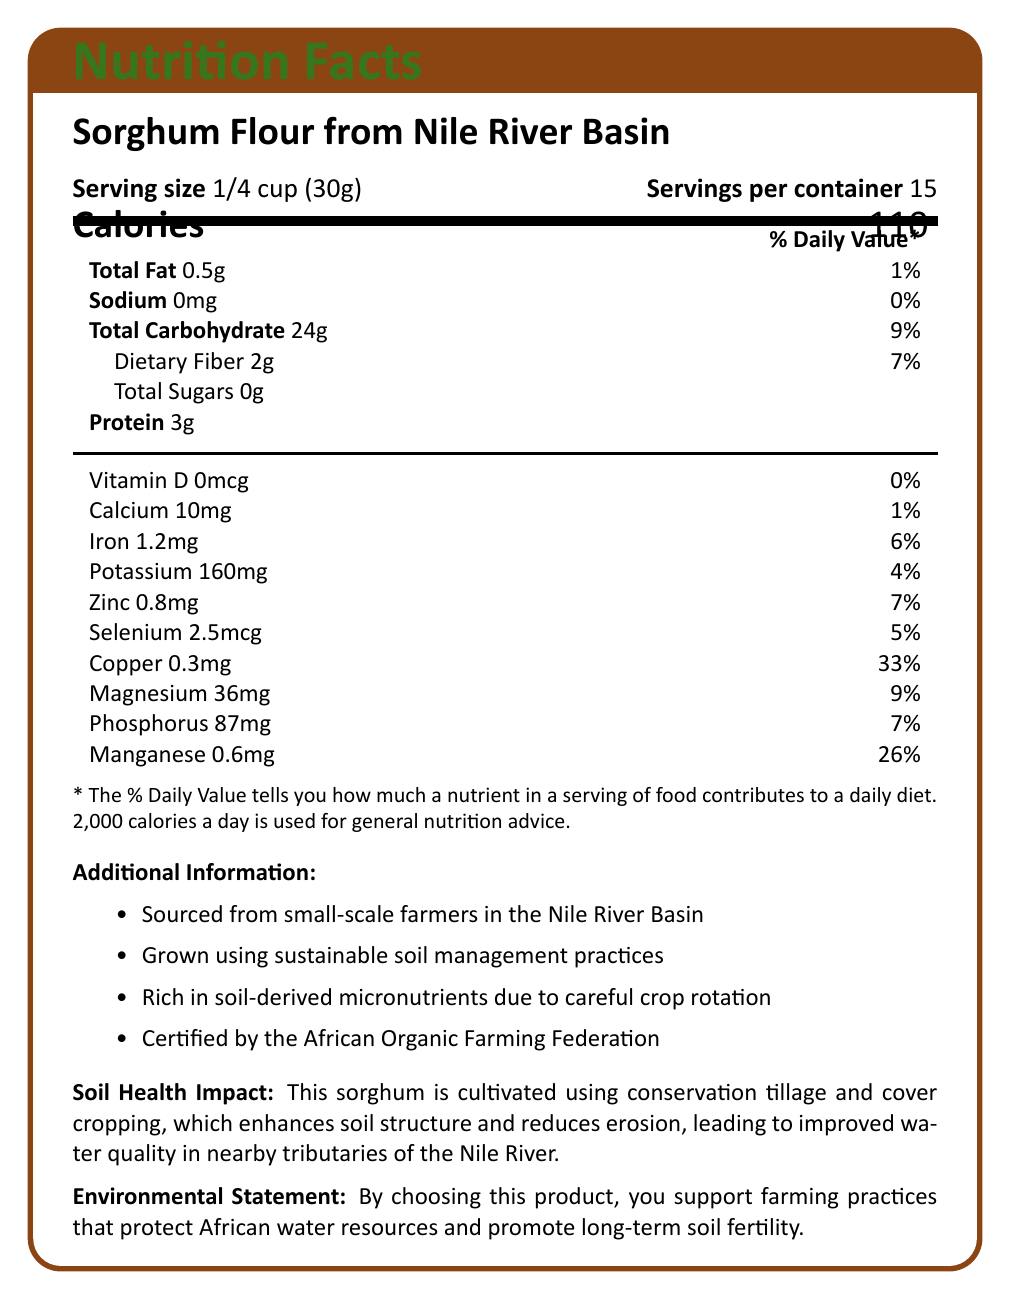what is the product name? The product name is displayed at the top of the document.
Answer: Sorghum Flour from Nile River Basin what is the serving size? The serving size is listed under the product name on the document.
Answer: 1/4 cup (30g) how many calories are in one serving? The caloric content per serving is listed in the section labeled "Calories."
Answer: 110 how much protein is in one serving? The amount of protein per serving is listed under the protein section.
Answer: 3g what percentage of the daily value for iron does one serving contain? The daily value percentage for iron is listed next to its amount.
Answer: 6% what is the total carbohydrate content per serving? A. 20g B. 24g C. 30g D. 36g The total carbohydrate content is listed under the "Total Carbohydrate" section.
Answer: B. 24g which nutrient has the highest daily value percentage? A. Sodium B. Calcium C. Copper D. Zinc Copper has a daily value percentage of 33%, which is the highest listed.
Answer: C. Copper is there any sodium in the product? The sodium content per serving is 0mg, as listed in the document.
Answer: No does this product support sustainable farming practices? The components under "Additional Information" and the "Environmental Statement" mention sustainable soil management practices and the protection of African water resources.
Answer: Yes what is the main idea of the document? The document includes detailed nutritional data, information about the sources and farming methods, and statements about the environmental impact and certification.
Answer: The document provides nutritional information for Sorghum Flour from the Nile River Basin, highlighting both its nutritional content and the sustainable farming practices used in its cultivation. how does conservation tillage affect soil health according to the document? According to the "Soil Health Impact" section, conservation tillage helps improve soil structure and reduces erosion.
Answer: It enhances soil structure and reduces erosion. what percentage of daily magnesium does one serving contain? The daily value percentage for magnesium is listed next to its amount in the nutrient section.
Answer: 9% how many servings are in the container? The number of servings per container is listed beneath the serving size.
Answer: 15 what are the main soil-derived micronutrients mentioned in the document? These micronutrients are listed in the nutrient section with their respective amounts and daily values.
Answer: Iron, Zinc, Selenium, Copper, Magnesium, Phosphorus, Manganese is the sorghum flour certified organic? The product is certified by the African Organic Farming Federation, as mentioned in the additional information.
Answer: Yes what is the amount and daily value percentage of phosphorus in one serving of sorghum flour? The phosphorus content and its daily value percentage are listed in the nutrient section.
Answer: 87mg, 7% how does the product contribute to water quality in nearby rivers? The "Soil Health Impact" section states that these practices improve water quality in nearby tributaries of the Nile River.
Answer: By using conservation tillage and cover cropping practices that reduce erosion what is the total fat content per serving? The total fat content is listed in the nutrient section under "Total Fat."
Answer: 0.5g what additional benefits besides nutrition does this product offer? The "Additional Information" and "Environmental Statement" sections highlight the environmental and sustainability benefits.
Answer: Promotes sustainable farming practices and protects African water resources where is the product sourced from? This information is provided in the "Additional Information" section.
Answer: Small-scale farmers in the Nile River Basin what type of image is included in the document? The "tikzpicture" section at the end includes an example image.
Answer: An example image (presumed to be of the product or related to it) how is the daily value percentage determined? The document does not provide details on how daily value percentages are calculated, only the percentages themselves are listed.
Answer: Not enough information 